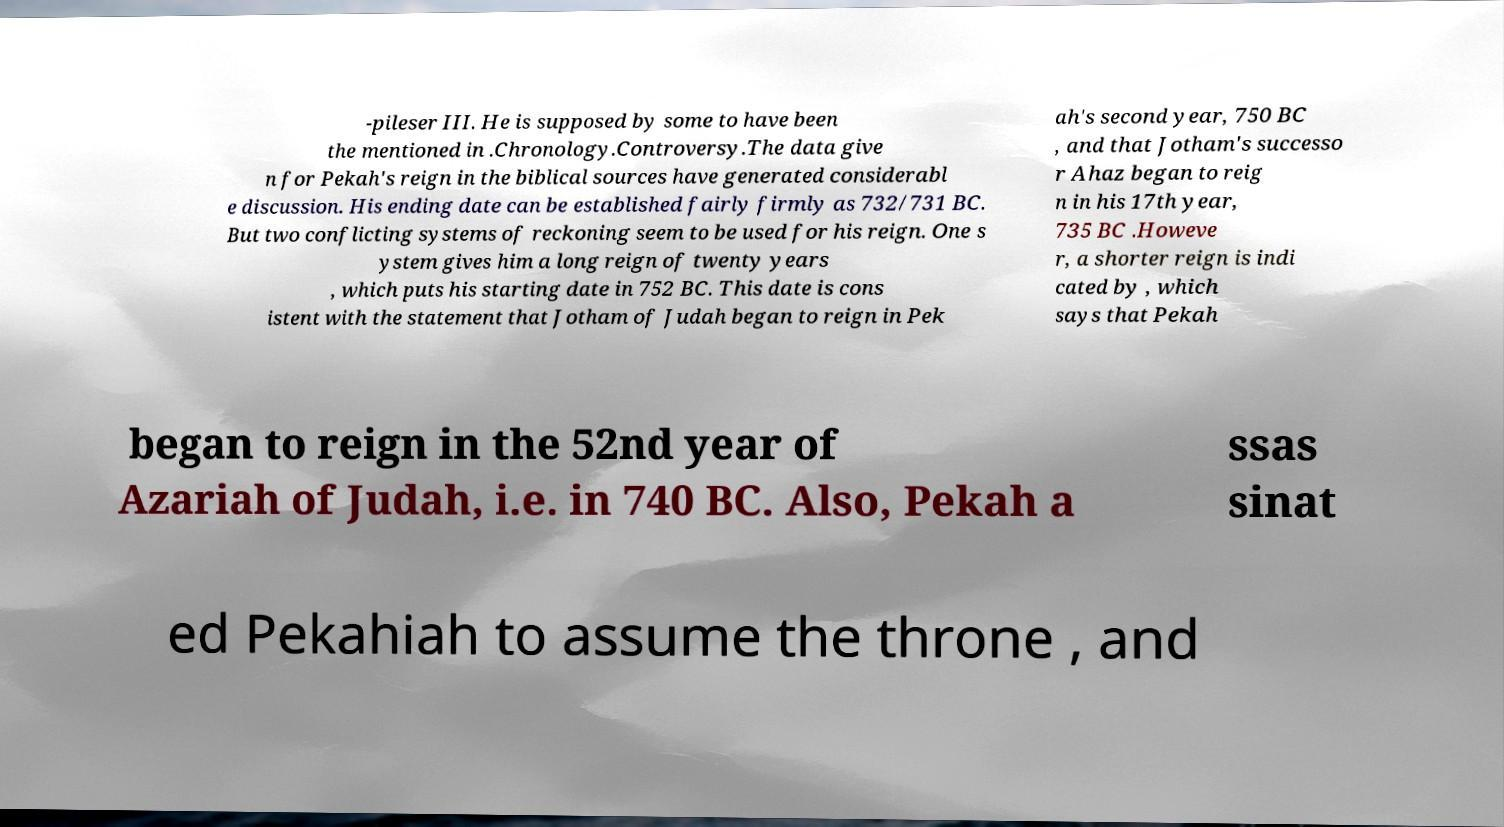Can you read and provide the text displayed in the image?This photo seems to have some interesting text. Can you extract and type it out for me? -pileser III. He is supposed by some to have been the mentioned in .Chronology.Controversy.The data give n for Pekah's reign in the biblical sources have generated considerabl e discussion. His ending date can be established fairly firmly as 732/731 BC. But two conflicting systems of reckoning seem to be used for his reign. One s ystem gives him a long reign of twenty years , which puts his starting date in 752 BC. This date is cons istent with the statement that Jotham of Judah began to reign in Pek ah's second year, 750 BC , and that Jotham's successo r Ahaz began to reig n in his 17th year, 735 BC .Howeve r, a shorter reign is indi cated by , which says that Pekah began to reign in the 52nd year of Azariah of Judah, i.e. in 740 BC. Also, Pekah a ssas sinat ed Pekahiah to assume the throne , and 